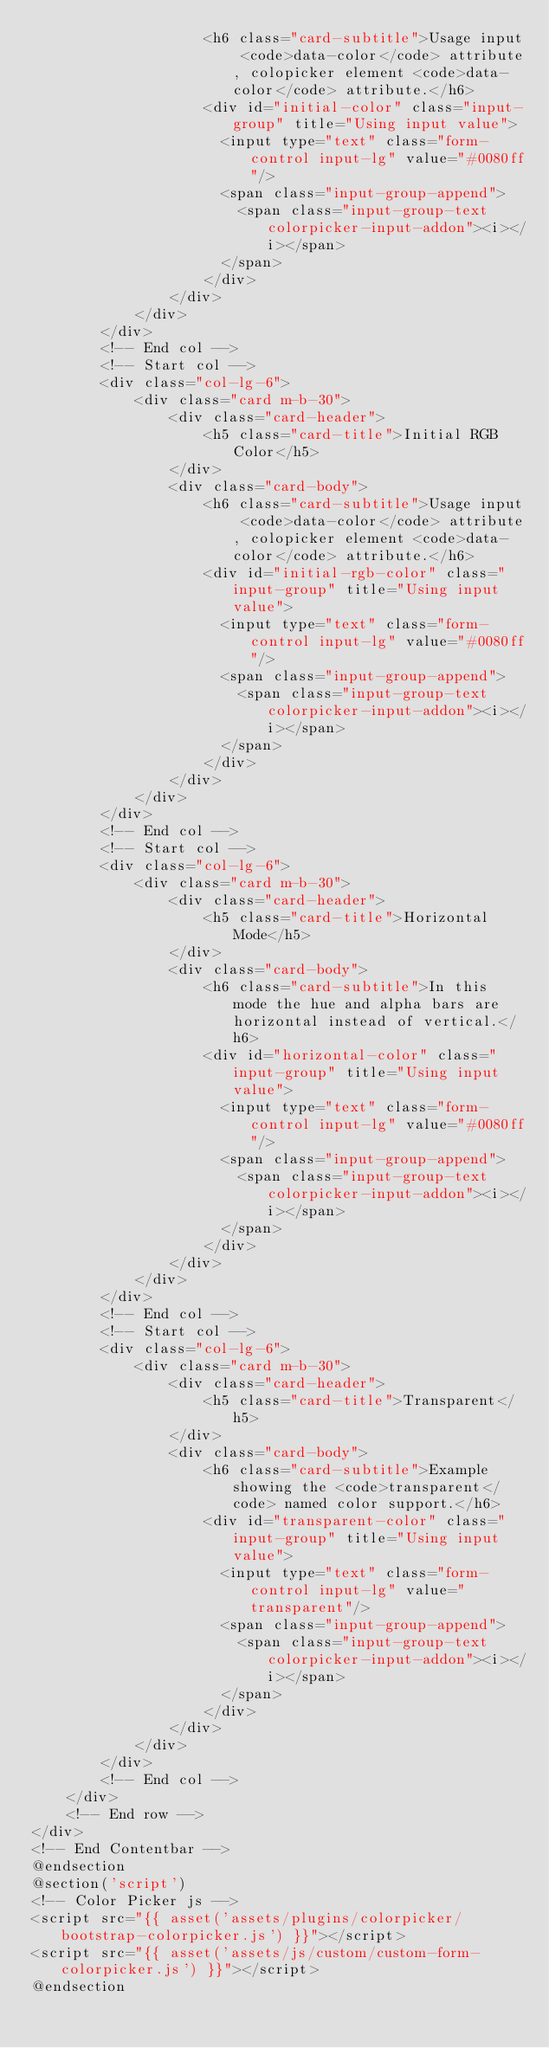Convert code to text. <code><loc_0><loc_0><loc_500><loc_500><_PHP_>                    <h6 class="card-subtitle">Usage input <code>data-color</code> attribute, colopicker element <code>data-color</code> attribute.</h6>
                    <div id="initial-color" class="input-group" title="Using input value">
                      <input type="text" class="form-control input-lg" value="#0080ff"/>
                      <span class="input-group-append">
                        <span class="input-group-text colorpicker-input-addon"><i></i></span>
                      </span>
                    </div>
                </div>
            </div>
        </div>  
        <!-- End col -->
        <!-- Start col -->
        <div class="col-lg-6">
            <div class="card m-b-30">
                <div class="card-header">
                    <h5 class="card-title">Initial RGB Color</h5>
                </div>
                <div class="card-body">
                    <h6 class="card-subtitle">Usage input <code>data-color</code> attribute, colopicker element <code>data-color</code> attribute.</h6>
                    <div id="initial-rgb-color" class="input-group" title="Using input value">
                      <input type="text" class="form-control input-lg" value="#0080ff"/>
                      <span class="input-group-append">
                        <span class="input-group-text colorpicker-input-addon"><i></i></span>
                      </span>
                    </div>
                </div>
            </div>
        </div>  
        <!-- End col -->
        <!-- Start col -->
        <div class="col-lg-6">
            <div class="card m-b-30">
                <div class="card-header">
                    <h5 class="card-title">Horizontal Mode</h5>
                </div>
                <div class="card-body">
                    <h6 class="card-subtitle">In this mode the hue and alpha bars are horizontal instead of vertical.</h6>
                    <div id="horizontal-color" class="input-group" title="Using input value">
                      <input type="text" class="form-control input-lg" value="#0080ff"/>
                      <span class="input-group-append">
                        <span class="input-group-text colorpicker-input-addon"><i></i></span>
                      </span>
                    </div>
                </div>
            </div>
        </div>  
        <!-- End col -->
        <!-- Start col -->
        <div class="col-lg-6">
            <div class="card m-b-30">
                <div class="card-header">
                    <h5 class="card-title">Transparent</h5>
                </div>
                <div class="card-body">
                    <h6 class="card-subtitle">Example showing the <code>transparent</code> named color support.</h6>
                    <div id="transparent-color" class="input-group" title="Using input value">
                      <input type="text" class="form-control input-lg" value="transparent"/>
                      <span class="input-group-append">
                        <span class="input-group-text colorpicker-input-addon"><i></i></span>
                      </span>
                    </div>
                </div>
            </div>
        </div>  
        <!-- End col -->
    </div> 
    <!-- End row -->
</div>
<!-- End Contentbar -->
@endsection 
@section('script')
<!-- Color Picker js -->
<script src="{{ asset('assets/plugins/colorpicker/bootstrap-colorpicker.js') }}"></script>
<script src="{{ asset('assets/js/custom/custom-form-colorpicker.js') }}"></script>
@endsection </code> 